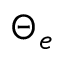<formula> <loc_0><loc_0><loc_500><loc_500>\Theta _ { e }</formula> 